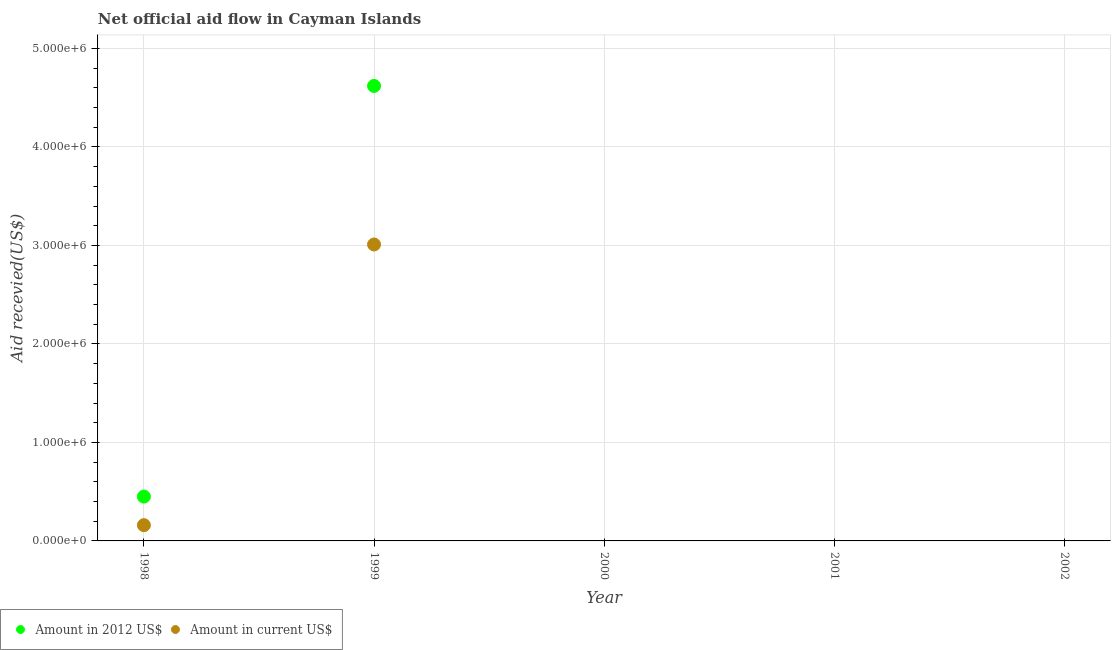Is the number of dotlines equal to the number of legend labels?
Offer a terse response. No. What is the amount of aid received(expressed in us$) in 1999?
Your answer should be compact. 3.01e+06. Across all years, what is the maximum amount of aid received(expressed in 2012 us$)?
Give a very brief answer. 4.62e+06. Across all years, what is the minimum amount of aid received(expressed in 2012 us$)?
Your response must be concise. 0. What is the total amount of aid received(expressed in 2012 us$) in the graph?
Ensure brevity in your answer.  5.07e+06. What is the difference between the amount of aid received(expressed in us$) in 1998 and that in 1999?
Your answer should be very brief. -2.85e+06. What is the difference between the amount of aid received(expressed in us$) in 2000 and the amount of aid received(expressed in 2012 us$) in 1998?
Provide a short and direct response. -4.50e+05. What is the average amount of aid received(expressed in us$) per year?
Provide a short and direct response. 6.34e+05. In the year 1998, what is the difference between the amount of aid received(expressed in 2012 us$) and amount of aid received(expressed in us$)?
Your answer should be compact. 2.90e+05. What is the difference between the highest and the lowest amount of aid received(expressed in us$)?
Provide a succinct answer. 3.01e+06. Is the amount of aid received(expressed in 2012 us$) strictly greater than the amount of aid received(expressed in us$) over the years?
Your answer should be compact. No. Is the amount of aid received(expressed in us$) strictly less than the amount of aid received(expressed in 2012 us$) over the years?
Keep it short and to the point. No. How many dotlines are there?
Offer a very short reply. 2. How many years are there in the graph?
Provide a short and direct response. 5. What is the difference between two consecutive major ticks on the Y-axis?
Keep it short and to the point. 1.00e+06. How many legend labels are there?
Offer a terse response. 2. How are the legend labels stacked?
Ensure brevity in your answer.  Horizontal. What is the title of the graph?
Ensure brevity in your answer.  Net official aid flow in Cayman Islands. Does "Resident workers" appear as one of the legend labels in the graph?
Your answer should be very brief. No. What is the label or title of the Y-axis?
Give a very brief answer. Aid recevied(US$). What is the Aid recevied(US$) of Amount in 2012 US$ in 1998?
Provide a succinct answer. 4.50e+05. What is the Aid recevied(US$) in Amount in current US$ in 1998?
Offer a terse response. 1.60e+05. What is the Aid recevied(US$) of Amount in 2012 US$ in 1999?
Offer a terse response. 4.62e+06. What is the Aid recevied(US$) in Amount in current US$ in 1999?
Your answer should be very brief. 3.01e+06. What is the Aid recevied(US$) in Amount in current US$ in 2000?
Provide a short and direct response. 0. What is the Aid recevied(US$) of Amount in 2012 US$ in 2001?
Provide a short and direct response. 0. What is the Aid recevied(US$) of Amount in current US$ in 2002?
Ensure brevity in your answer.  0. Across all years, what is the maximum Aid recevied(US$) in Amount in 2012 US$?
Your response must be concise. 4.62e+06. Across all years, what is the maximum Aid recevied(US$) of Amount in current US$?
Provide a succinct answer. 3.01e+06. Across all years, what is the minimum Aid recevied(US$) in Amount in 2012 US$?
Give a very brief answer. 0. What is the total Aid recevied(US$) of Amount in 2012 US$ in the graph?
Offer a very short reply. 5.07e+06. What is the total Aid recevied(US$) in Amount in current US$ in the graph?
Your answer should be very brief. 3.17e+06. What is the difference between the Aid recevied(US$) of Amount in 2012 US$ in 1998 and that in 1999?
Give a very brief answer. -4.17e+06. What is the difference between the Aid recevied(US$) in Amount in current US$ in 1998 and that in 1999?
Make the answer very short. -2.85e+06. What is the difference between the Aid recevied(US$) in Amount in 2012 US$ in 1998 and the Aid recevied(US$) in Amount in current US$ in 1999?
Your answer should be compact. -2.56e+06. What is the average Aid recevied(US$) of Amount in 2012 US$ per year?
Provide a short and direct response. 1.01e+06. What is the average Aid recevied(US$) in Amount in current US$ per year?
Ensure brevity in your answer.  6.34e+05. In the year 1999, what is the difference between the Aid recevied(US$) of Amount in 2012 US$ and Aid recevied(US$) of Amount in current US$?
Ensure brevity in your answer.  1.61e+06. What is the ratio of the Aid recevied(US$) in Amount in 2012 US$ in 1998 to that in 1999?
Your answer should be very brief. 0.1. What is the ratio of the Aid recevied(US$) of Amount in current US$ in 1998 to that in 1999?
Give a very brief answer. 0.05. What is the difference between the highest and the lowest Aid recevied(US$) of Amount in 2012 US$?
Ensure brevity in your answer.  4.62e+06. What is the difference between the highest and the lowest Aid recevied(US$) of Amount in current US$?
Your answer should be compact. 3.01e+06. 